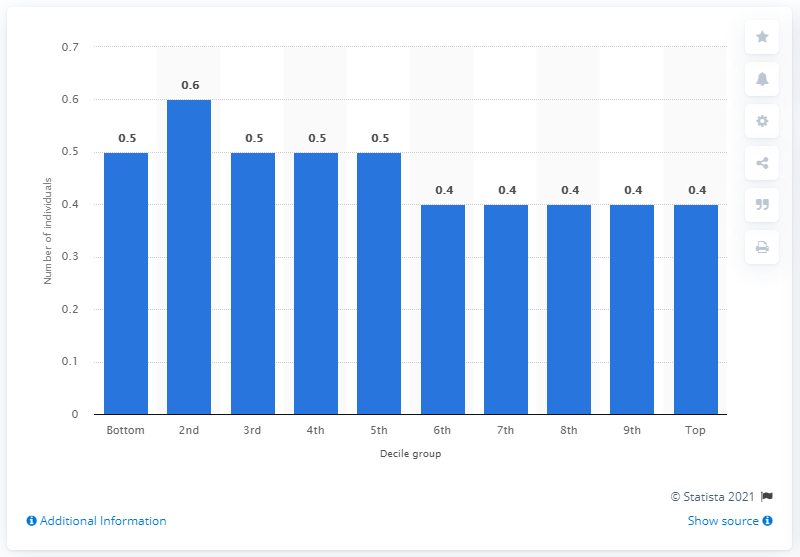Highlight a few significant elements in this photo. The average number of children per household in the top decile group was 0.4 children. 